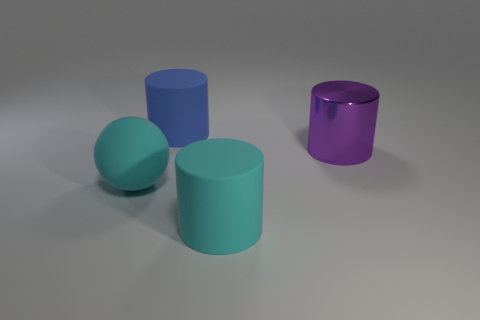Is there anything else that has the same material as the purple cylinder?
Make the answer very short. No. What is the color of the matte sphere?
Provide a short and direct response. Cyan. What is the color of the big matte thing that is to the left of the matte thing behind the large metal thing?
Ensure brevity in your answer.  Cyan. Is there a cyan ball made of the same material as the blue cylinder?
Offer a very short reply. Yes. What material is the large purple object that is in front of the big cylinder that is behind the big purple cylinder?
Make the answer very short. Metal. How many gray metal things have the same shape as the large blue object?
Make the answer very short. 0. The large blue rubber thing has what shape?
Provide a succinct answer. Cylinder. Are there fewer shiny cylinders than tiny red balls?
Your response must be concise. No. What material is the large blue thing that is the same shape as the large purple object?
Provide a succinct answer. Rubber. Are there more gray metal cubes than cyan matte balls?
Your response must be concise. No. 